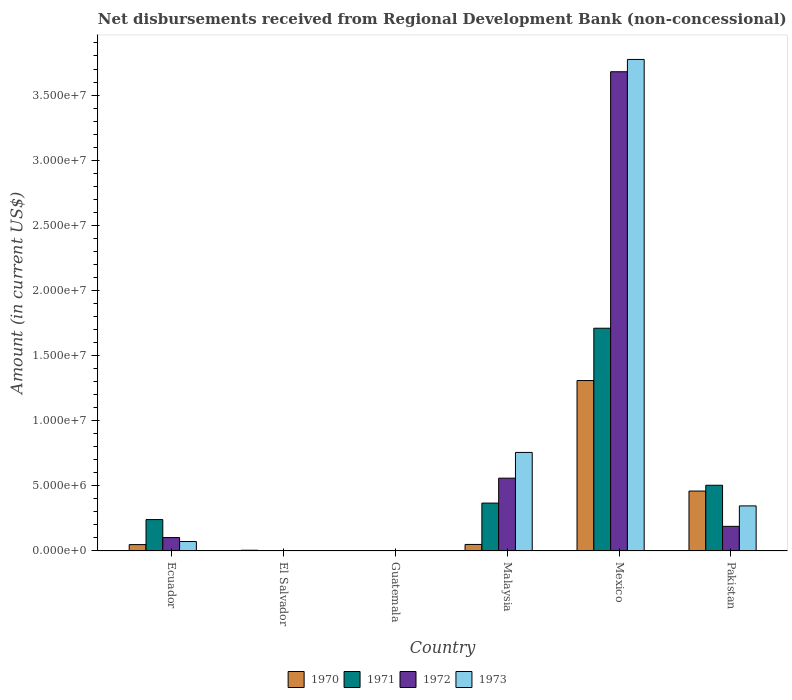Are the number of bars on each tick of the X-axis equal?
Provide a succinct answer. No. How many bars are there on the 4th tick from the left?
Provide a succinct answer. 4. What is the label of the 2nd group of bars from the left?
Your answer should be compact. El Salvador. In how many cases, is the number of bars for a given country not equal to the number of legend labels?
Give a very brief answer. 2. What is the amount of disbursements received from Regional Development Bank in 1971 in Ecuador?
Offer a very short reply. 2.41e+06. Across all countries, what is the maximum amount of disbursements received from Regional Development Bank in 1970?
Make the answer very short. 1.31e+07. Across all countries, what is the minimum amount of disbursements received from Regional Development Bank in 1973?
Ensure brevity in your answer.  0. What is the total amount of disbursements received from Regional Development Bank in 1971 in the graph?
Your response must be concise. 2.82e+07. What is the difference between the amount of disbursements received from Regional Development Bank in 1970 in Ecuador and that in Malaysia?
Provide a succinct answer. -1.30e+04. What is the difference between the amount of disbursements received from Regional Development Bank in 1972 in Pakistan and the amount of disbursements received from Regional Development Bank in 1971 in El Salvador?
Offer a terse response. 1.89e+06. What is the average amount of disbursements received from Regional Development Bank in 1973 per country?
Give a very brief answer. 8.25e+06. What is the difference between the amount of disbursements received from Regional Development Bank of/in 1972 and amount of disbursements received from Regional Development Bank of/in 1971 in Mexico?
Provide a short and direct response. 1.97e+07. What is the ratio of the amount of disbursements received from Regional Development Bank in 1971 in Ecuador to that in Pakistan?
Your answer should be very brief. 0.48. Is the amount of disbursements received from Regional Development Bank in 1970 in Mexico less than that in Pakistan?
Make the answer very short. No. Is the difference between the amount of disbursements received from Regional Development Bank in 1972 in Ecuador and Mexico greater than the difference between the amount of disbursements received from Regional Development Bank in 1971 in Ecuador and Mexico?
Make the answer very short. No. What is the difference between the highest and the second highest amount of disbursements received from Regional Development Bank in 1973?
Your response must be concise. 3.43e+07. What is the difference between the highest and the lowest amount of disbursements received from Regional Development Bank in 1970?
Provide a short and direct response. 1.31e+07. How many bars are there?
Provide a succinct answer. 17. Are all the bars in the graph horizontal?
Provide a short and direct response. No. How many countries are there in the graph?
Your answer should be very brief. 6. Does the graph contain grids?
Provide a succinct answer. No. Where does the legend appear in the graph?
Provide a short and direct response. Bottom center. How many legend labels are there?
Make the answer very short. 4. How are the legend labels stacked?
Your response must be concise. Horizontal. What is the title of the graph?
Ensure brevity in your answer.  Net disbursements received from Regional Development Bank (non-concessional). Does "1984" appear as one of the legend labels in the graph?
Offer a very short reply. No. What is the Amount (in current US$) in 1970 in Ecuador?
Make the answer very short. 4.89e+05. What is the Amount (in current US$) in 1971 in Ecuador?
Make the answer very short. 2.41e+06. What is the Amount (in current US$) in 1972 in Ecuador?
Offer a very short reply. 1.03e+06. What is the Amount (in current US$) in 1973 in Ecuador?
Offer a terse response. 7.26e+05. What is the Amount (in current US$) in 1970 in El Salvador?
Your answer should be compact. 5.70e+04. What is the Amount (in current US$) in 1971 in El Salvador?
Provide a short and direct response. 0. What is the Amount (in current US$) in 1973 in El Salvador?
Provide a succinct answer. 0. What is the Amount (in current US$) of 1970 in Malaysia?
Make the answer very short. 5.02e+05. What is the Amount (in current US$) of 1971 in Malaysia?
Provide a succinct answer. 3.68e+06. What is the Amount (in current US$) in 1972 in Malaysia?
Provide a short and direct response. 5.59e+06. What is the Amount (in current US$) of 1973 in Malaysia?
Your response must be concise. 7.57e+06. What is the Amount (in current US$) in 1970 in Mexico?
Your answer should be compact. 1.31e+07. What is the Amount (in current US$) of 1971 in Mexico?
Your answer should be very brief. 1.71e+07. What is the Amount (in current US$) in 1972 in Mexico?
Provide a succinct answer. 3.68e+07. What is the Amount (in current US$) in 1973 in Mexico?
Keep it short and to the point. 3.77e+07. What is the Amount (in current US$) of 1970 in Pakistan?
Offer a very short reply. 4.60e+06. What is the Amount (in current US$) of 1971 in Pakistan?
Ensure brevity in your answer.  5.04e+06. What is the Amount (in current US$) of 1972 in Pakistan?
Offer a very short reply. 1.89e+06. What is the Amount (in current US$) in 1973 in Pakistan?
Make the answer very short. 3.46e+06. Across all countries, what is the maximum Amount (in current US$) in 1970?
Provide a short and direct response. 1.31e+07. Across all countries, what is the maximum Amount (in current US$) in 1971?
Offer a terse response. 1.71e+07. Across all countries, what is the maximum Amount (in current US$) of 1972?
Make the answer very short. 3.68e+07. Across all countries, what is the maximum Amount (in current US$) in 1973?
Give a very brief answer. 3.77e+07. Across all countries, what is the minimum Amount (in current US$) in 1970?
Your answer should be compact. 0. Across all countries, what is the minimum Amount (in current US$) of 1972?
Offer a very short reply. 0. What is the total Amount (in current US$) in 1970 in the graph?
Provide a succinct answer. 1.87e+07. What is the total Amount (in current US$) in 1971 in the graph?
Ensure brevity in your answer.  2.82e+07. What is the total Amount (in current US$) of 1972 in the graph?
Your answer should be compact. 4.53e+07. What is the total Amount (in current US$) in 1973 in the graph?
Offer a terse response. 4.95e+07. What is the difference between the Amount (in current US$) of 1970 in Ecuador and that in El Salvador?
Offer a terse response. 4.32e+05. What is the difference between the Amount (in current US$) in 1970 in Ecuador and that in Malaysia?
Ensure brevity in your answer.  -1.30e+04. What is the difference between the Amount (in current US$) in 1971 in Ecuador and that in Malaysia?
Your answer should be very brief. -1.27e+06. What is the difference between the Amount (in current US$) of 1972 in Ecuador and that in Malaysia?
Provide a short and direct response. -4.56e+06. What is the difference between the Amount (in current US$) of 1973 in Ecuador and that in Malaysia?
Offer a very short reply. -6.84e+06. What is the difference between the Amount (in current US$) of 1970 in Ecuador and that in Mexico?
Your answer should be compact. -1.26e+07. What is the difference between the Amount (in current US$) of 1971 in Ecuador and that in Mexico?
Offer a very short reply. -1.47e+07. What is the difference between the Amount (in current US$) of 1972 in Ecuador and that in Mexico?
Keep it short and to the point. -3.58e+07. What is the difference between the Amount (in current US$) in 1973 in Ecuador and that in Mexico?
Offer a very short reply. -3.70e+07. What is the difference between the Amount (in current US$) in 1970 in Ecuador and that in Pakistan?
Your answer should be compact. -4.11e+06. What is the difference between the Amount (in current US$) of 1971 in Ecuador and that in Pakistan?
Ensure brevity in your answer.  -2.63e+06. What is the difference between the Amount (in current US$) in 1972 in Ecuador and that in Pakistan?
Keep it short and to the point. -8.59e+05. What is the difference between the Amount (in current US$) of 1973 in Ecuador and that in Pakistan?
Your answer should be very brief. -2.74e+06. What is the difference between the Amount (in current US$) in 1970 in El Salvador and that in Malaysia?
Offer a terse response. -4.45e+05. What is the difference between the Amount (in current US$) in 1970 in El Salvador and that in Mexico?
Make the answer very short. -1.30e+07. What is the difference between the Amount (in current US$) of 1970 in El Salvador and that in Pakistan?
Give a very brief answer. -4.54e+06. What is the difference between the Amount (in current US$) in 1970 in Malaysia and that in Mexico?
Offer a very short reply. -1.26e+07. What is the difference between the Amount (in current US$) in 1971 in Malaysia and that in Mexico?
Provide a succinct answer. -1.34e+07. What is the difference between the Amount (in current US$) of 1972 in Malaysia and that in Mexico?
Make the answer very short. -3.12e+07. What is the difference between the Amount (in current US$) of 1973 in Malaysia and that in Mexico?
Keep it short and to the point. -3.02e+07. What is the difference between the Amount (in current US$) of 1970 in Malaysia and that in Pakistan?
Give a very brief answer. -4.10e+06. What is the difference between the Amount (in current US$) of 1971 in Malaysia and that in Pakistan?
Offer a very short reply. -1.37e+06. What is the difference between the Amount (in current US$) in 1972 in Malaysia and that in Pakistan?
Keep it short and to the point. 3.70e+06. What is the difference between the Amount (in current US$) in 1973 in Malaysia and that in Pakistan?
Offer a terse response. 4.10e+06. What is the difference between the Amount (in current US$) of 1970 in Mexico and that in Pakistan?
Give a very brief answer. 8.48e+06. What is the difference between the Amount (in current US$) of 1971 in Mexico and that in Pakistan?
Keep it short and to the point. 1.21e+07. What is the difference between the Amount (in current US$) in 1972 in Mexico and that in Pakistan?
Make the answer very short. 3.49e+07. What is the difference between the Amount (in current US$) in 1973 in Mexico and that in Pakistan?
Make the answer very short. 3.43e+07. What is the difference between the Amount (in current US$) in 1970 in Ecuador and the Amount (in current US$) in 1971 in Malaysia?
Offer a terse response. -3.19e+06. What is the difference between the Amount (in current US$) of 1970 in Ecuador and the Amount (in current US$) of 1972 in Malaysia?
Ensure brevity in your answer.  -5.10e+06. What is the difference between the Amount (in current US$) in 1970 in Ecuador and the Amount (in current US$) in 1973 in Malaysia?
Provide a succinct answer. -7.08e+06. What is the difference between the Amount (in current US$) in 1971 in Ecuador and the Amount (in current US$) in 1972 in Malaysia?
Offer a very short reply. -3.18e+06. What is the difference between the Amount (in current US$) in 1971 in Ecuador and the Amount (in current US$) in 1973 in Malaysia?
Your response must be concise. -5.16e+06. What is the difference between the Amount (in current US$) of 1972 in Ecuador and the Amount (in current US$) of 1973 in Malaysia?
Offer a terse response. -6.54e+06. What is the difference between the Amount (in current US$) of 1970 in Ecuador and the Amount (in current US$) of 1971 in Mexico?
Your answer should be compact. -1.66e+07. What is the difference between the Amount (in current US$) of 1970 in Ecuador and the Amount (in current US$) of 1972 in Mexico?
Your answer should be very brief. -3.63e+07. What is the difference between the Amount (in current US$) in 1970 in Ecuador and the Amount (in current US$) in 1973 in Mexico?
Give a very brief answer. -3.72e+07. What is the difference between the Amount (in current US$) of 1971 in Ecuador and the Amount (in current US$) of 1972 in Mexico?
Provide a succinct answer. -3.44e+07. What is the difference between the Amount (in current US$) of 1971 in Ecuador and the Amount (in current US$) of 1973 in Mexico?
Offer a very short reply. -3.53e+07. What is the difference between the Amount (in current US$) of 1972 in Ecuador and the Amount (in current US$) of 1973 in Mexico?
Your answer should be very brief. -3.67e+07. What is the difference between the Amount (in current US$) of 1970 in Ecuador and the Amount (in current US$) of 1971 in Pakistan?
Provide a succinct answer. -4.56e+06. What is the difference between the Amount (in current US$) of 1970 in Ecuador and the Amount (in current US$) of 1972 in Pakistan?
Provide a succinct answer. -1.40e+06. What is the difference between the Amount (in current US$) in 1970 in Ecuador and the Amount (in current US$) in 1973 in Pakistan?
Provide a succinct answer. -2.97e+06. What is the difference between the Amount (in current US$) in 1971 in Ecuador and the Amount (in current US$) in 1972 in Pakistan?
Make the answer very short. 5.21e+05. What is the difference between the Amount (in current US$) in 1971 in Ecuador and the Amount (in current US$) in 1973 in Pakistan?
Your answer should be very brief. -1.05e+06. What is the difference between the Amount (in current US$) in 1972 in Ecuador and the Amount (in current US$) in 1973 in Pakistan?
Your response must be concise. -2.43e+06. What is the difference between the Amount (in current US$) in 1970 in El Salvador and the Amount (in current US$) in 1971 in Malaysia?
Provide a succinct answer. -3.62e+06. What is the difference between the Amount (in current US$) of 1970 in El Salvador and the Amount (in current US$) of 1972 in Malaysia?
Make the answer very short. -5.53e+06. What is the difference between the Amount (in current US$) in 1970 in El Salvador and the Amount (in current US$) in 1973 in Malaysia?
Provide a succinct answer. -7.51e+06. What is the difference between the Amount (in current US$) in 1970 in El Salvador and the Amount (in current US$) in 1971 in Mexico?
Make the answer very short. -1.70e+07. What is the difference between the Amount (in current US$) in 1970 in El Salvador and the Amount (in current US$) in 1972 in Mexico?
Provide a succinct answer. -3.67e+07. What is the difference between the Amount (in current US$) of 1970 in El Salvador and the Amount (in current US$) of 1973 in Mexico?
Offer a very short reply. -3.77e+07. What is the difference between the Amount (in current US$) in 1970 in El Salvador and the Amount (in current US$) in 1971 in Pakistan?
Keep it short and to the point. -4.99e+06. What is the difference between the Amount (in current US$) in 1970 in El Salvador and the Amount (in current US$) in 1972 in Pakistan?
Make the answer very short. -1.83e+06. What is the difference between the Amount (in current US$) of 1970 in El Salvador and the Amount (in current US$) of 1973 in Pakistan?
Ensure brevity in your answer.  -3.40e+06. What is the difference between the Amount (in current US$) in 1970 in Malaysia and the Amount (in current US$) in 1971 in Mexico?
Keep it short and to the point. -1.66e+07. What is the difference between the Amount (in current US$) in 1970 in Malaysia and the Amount (in current US$) in 1972 in Mexico?
Your answer should be very brief. -3.63e+07. What is the difference between the Amount (in current US$) of 1970 in Malaysia and the Amount (in current US$) of 1973 in Mexico?
Offer a terse response. -3.72e+07. What is the difference between the Amount (in current US$) of 1971 in Malaysia and the Amount (in current US$) of 1972 in Mexico?
Make the answer very short. -3.31e+07. What is the difference between the Amount (in current US$) in 1971 in Malaysia and the Amount (in current US$) in 1973 in Mexico?
Keep it short and to the point. -3.41e+07. What is the difference between the Amount (in current US$) of 1972 in Malaysia and the Amount (in current US$) of 1973 in Mexico?
Ensure brevity in your answer.  -3.21e+07. What is the difference between the Amount (in current US$) of 1970 in Malaysia and the Amount (in current US$) of 1971 in Pakistan?
Give a very brief answer. -4.54e+06. What is the difference between the Amount (in current US$) in 1970 in Malaysia and the Amount (in current US$) in 1972 in Pakistan?
Ensure brevity in your answer.  -1.39e+06. What is the difference between the Amount (in current US$) of 1970 in Malaysia and the Amount (in current US$) of 1973 in Pakistan?
Keep it short and to the point. -2.96e+06. What is the difference between the Amount (in current US$) of 1971 in Malaysia and the Amount (in current US$) of 1972 in Pakistan?
Offer a terse response. 1.79e+06. What is the difference between the Amount (in current US$) of 1971 in Malaysia and the Amount (in current US$) of 1973 in Pakistan?
Provide a succinct answer. 2.16e+05. What is the difference between the Amount (in current US$) in 1972 in Malaysia and the Amount (in current US$) in 1973 in Pakistan?
Ensure brevity in your answer.  2.13e+06. What is the difference between the Amount (in current US$) in 1970 in Mexico and the Amount (in current US$) in 1971 in Pakistan?
Your answer should be compact. 8.04e+06. What is the difference between the Amount (in current US$) of 1970 in Mexico and the Amount (in current US$) of 1972 in Pakistan?
Your answer should be compact. 1.12e+07. What is the difference between the Amount (in current US$) of 1970 in Mexico and the Amount (in current US$) of 1973 in Pakistan?
Keep it short and to the point. 9.62e+06. What is the difference between the Amount (in current US$) in 1971 in Mexico and the Amount (in current US$) in 1972 in Pakistan?
Ensure brevity in your answer.  1.52e+07. What is the difference between the Amount (in current US$) of 1971 in Mexico and the Amount (in current US$) of 1973 in Pakistan?
Make the answer very short. 1.36e+07. What is the difference between the Amount (in current US$) in 1972 in Mexico and the Amount (in current US$) in 1973 in Pakistan?
Offer a very short reply. 3.33e+07. What is the average Amount (in current US$) of 1970 per country?
Your answer should be compact. 3.12e+06. What is the average Amount (in current US$) in 1971 per country?
Your response must be concise. 4.71e+06. What is the average Amount (in current US$) in 1972 per country?
Ensure brevity in your answer.  7.55e+06. What is the average Amount (in current US$) in 1973 per country?
Offer a very short reply. 8.25e+06. What is the difference between the Amount (in current US$) of 1970 and Amount (in current US$) of 1971 in Ecuador?
Ensure brevity in your answer.  -1.92e+06. What is the difference between the Amount (in current US$) of 1970 and Amount (in current US$) of 1972 in Ecuador?
Offer a very short reply. -5.42e+05. What is the difference between the Amount (in current US$) of 1970 and Amount (in current US$) of 1973 in Ecuador?
Offer a very short reply. -2.37e+05. What is the difference between the Amount (in current US$) in 1971 and Amount (in current US$) in 1972 in Ecuador?
Provide a succinct answer. 1.38e+06. What is the difference between the Amount (in current US$) of 1971 and Amount (in current US$) of 1973 in Ecuador?
Provide a succinct answer. 1.68e+06. What is the difference between the Amount (in current US$) of 1972 and Amount (in current US$) of 1973 in Ecuador?
Your answer should be very brief. 3.05e+05. What is the difference between the Amount (in current US$) in 1970 and Amount (in current US$) in 1971 in Malaysia?
Ensure brevity in your answer.  -3.18e+06. What is the difference between the Amount (in current US$) in 1970 and Amount (in current US$) in 1972 in Malaysia?
Make the answer very short. -5.09e+06. What is the difference between the Amount (in current US$) in 1970 and Amount (in current US$) in 1973 in Malaysia?
Offer a terse response. -7.06e+06. What is the difference between the Amount (in current US$) of 1971 and Amount (in current US$) of 1972 in Malaysia?
Your answer should be very brief. -1.91e+06. What is the difference between the Amount (in current US$) of 1971 and Amount (in current US$) of 1973 in Malaysia?
Give a very brief answer. -3.89e+06. What is the difference between the Amount (in current US$) in 1972 and Amount (in current US$) in 1973 in Malaysia?
Make the answer very short. -1.98e+06. What is the difference between the Amount (in current US$) of 1970 and Amount (in current US$) of 1971 in Mexico?
Provide a succinct answer. -4.02e+06. What is the difference between the Amount (in current US$) in 1970 and Amount (in current US$) in 1972 in Mexico?
Your response must be concise. -2.37e+07. What is the difference between the Amount (in current US$) in 1970 and Amount (in current US$) in 1973 in Mexico?
Make the answer very short. -2.46e+07. What is the difference between the Amount (in current US$) in 1971 and Amount (in current US$) in 1972 in Mexico?
Provide a short and direct response. -1.97e+07. What is the difference between the Amount (in current US$) of 1971 and Amount (in current US$) of 1973 in Mexico?
Your response must be concise. -2.06e+07. What is the difference between the Amount (in current US$) of 1972 and Amount (in current US$) of 1973 in Mexico?
Give a very brief answer. -9.43e+05. What is the difference between the Amount (in current US$) of 1970 and Amount (in current US$) of 1971 in Pakistan?
Offer a very short reply. -4.45e+05. What is the difference between the Amount (in current US$) of 1970 and Amount (in current US$) of 1972 in Pakistan?
Give a very brief answer. 2.71e+06. What is the difference between the Amount (in current US$) of 1970 and Amount (in current US$) of 1973 in Pakistan?
Ensure brevity in your answer.  1.14e+06. What is the difference between the Amount (in current US$) of 1971 and Amount (in current US$) of 1972 in Pakistan?
Offer a very short reply. 3.16e+06. What is the difference between the Amount (in current US$) of 1971 and Amount (in current US$) of 1973 in Pakistan?
Offer a terse response. 1.58e+06. What is the difference between the Amount (in current US$) of 1972 and Amount (in current US$) of 1973 in Pakistan?
Offer a very short reply. -1.57e+06. What is the ratio of the Amount (in current US$) of 1970 in Ecuador to that in El Salvador?
Your answer should be compact. 8.58. What is the ratio of the Amount (in current US$) in 1970 in Ecuador to that in Malaysia?
Your answer should be very brief. 0.97. What is the ratio of the Amount (in current US$) in 1971 in Ecuador to that in Malaysia?
Make the answer very short. 0.66. What is the ratio of the Amount (in current US$) of 1972 in Ecuador to that in Malaysia?
Offer a very short reply. 0.18. What is the ratio of the Amount (in current US$) of 1973 in Ecuador to that in Malaysia?
Provide a succinct answer. 0.1. What is the ratio of the Amount (in current US$) of 1970 in Ecuador to that in Mexico?
Make the answer very short. 0.04. What is the ratio of the Amount (in current US$) in 1971 in Ecuador to that in Mexico?
Provide a short and direct response. 0.14. What is the ratio of the Amount (in current US$) of 1972 in Ecuador to that in Mexico?
Provide a short and direct response. 0.03. What is the ratio of the Amount (in current US$) in 1973 in Ecuador to that in Mexico?
Your answer should be compact. 0.02. What is the ratio of the Amount (in current US$) in 1970 in Ecuador to that in Pakistan?
Your answer should be very brief. 0.11. What is the ratio of the Amount (in current US$) in 1971 in Ecuador to that in Pakistan?
Give a very brief answer. 0.48. What is the ratio of the Amount (in current US$) of 1972 in Ecuador to that in Pakistan?
Your answer should be very brief. 0.55. What is the ratio of the Amount (in current US$) in 1973 in Ecuador to that in Pakistan?
Make the answer very short. 0.21. What is the ratio of the Amount (in current US$) in 1970 in El Salvador to that in Malaysia?
Make the answer very short. 0.11. What is the ratio of the Amount (in current US$) of 1970 in El Salvador to that in Mexico?
Make the answer very short. 0. What is the ratio of the Amount (in current US$) in 1970 in El Salvador to that in Pakistan?
Make the answer very short. 0.01. What is the ratio of the Amount (in current US$) in 1970 in Malaysia to that in Mexico?
Your answer should be compact. 0.04. What is the ratio of the Amount (in current US$) of 1971 in Malaysia to that in Mexico?
Your response must be concise. 0.21. What is the ratio of the Amount (in current US$) in 1972 in Malaysia to that in Mexico?
Your answer should be compact. 0.15. What is the ratio of the Amount (in current US$) of 1973 in Malaysia to that in Mexico?
Make the answer very short. 0.2. What is the ratio of the Amount (in current US$) of 1970 in Malaysia to that in Pakistan?
Keep it short and to the point. 0.11. What is the ratio of the Amount (in current US$) of 1971 in Malaysia to that in Pakistan?
Provide a succinct answer. 0.73. What is the ratio of the Amount (in current US$) of 1972 in Malaysia to that in Pakistan?
Your answer should be compact. 2.96. What is the ratio of the Amount (in current US$) of 1973 in Malaysia to that in Pakistan?
Your answer should be very brief. 2.19. What is the ratio of the Amount (in current US$) of 1970 in Mexico to that in Pakistan?
Ensure brevity in your answer.  2.84. What is the ratio of the Amount (in current US$) of 1971 in Mexico to that in Pakistan?
Offer a terse response. 3.39. What is the ratio of the Amount (in current US$) of 1972 in Mexico to that in Pakistan?
Provide a succinct answer. 19.47. What is the ratio of the Amount (in current US$) of 1973 in Mexico to that in Pakistan?
Provide a succinct answer. 10.9. What is the difference between the highest and the second highest Amount (in current US$) of 1970?
Your answer should be very brief. 8.48e+06. What is the difference between the highest and the second highest Amount (in current US$) in 1971?
Your response must be concise. 1.21e+07. What is the difference between the highest and the second highest Amount (in current US$) of 1972?
Keep it short and to the point. 3.12e+07. What is the difference between the highest and the second highest Amount (in current US$) in 1973?
Keep it short and to the point. 3.02e+07. What is the difference between the highest and the lowest Amount (in current US$) of 1970?
Provide a short and direct response. 1.31e+07. What is the difference between the highest and the lowest Amount (in current US$) in 1971?
Provide a succinct answer. 1.71e+07. What is the difference between the highest and the lowest Amount (in current US$) of 1972?
Your answer should be very brief. 3.68e+07. What is the difference between the highest and the lowest Amount (in current US$) of 1973?
Your answer should be very brief. 3.77e+07. 